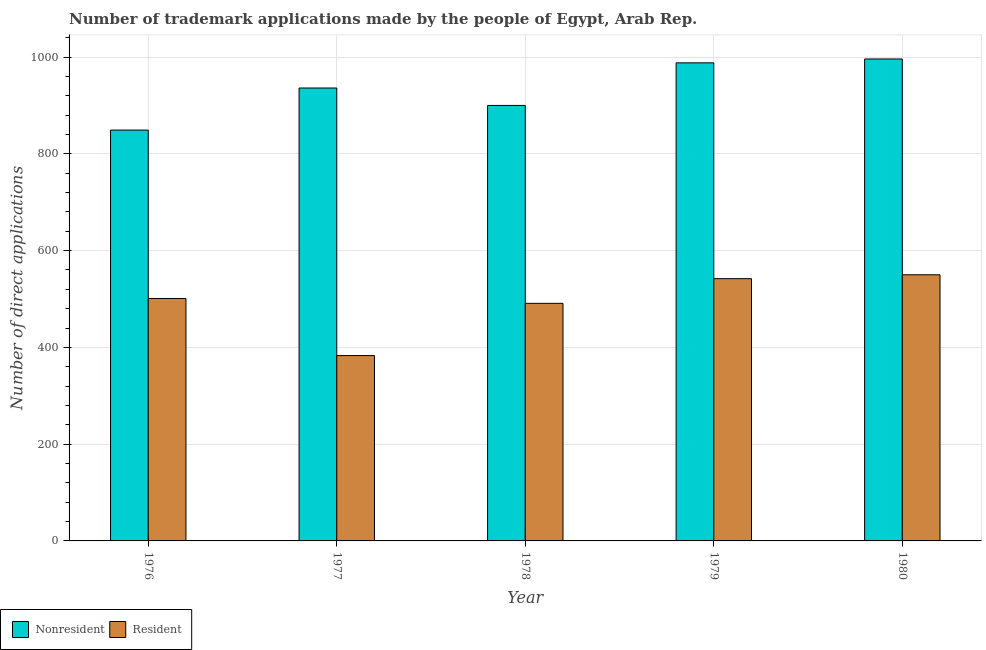Are the number of bars per tick equal to the number of legend labels?
Offer a very short reply. Yes. How many bars are there on the 1st tick from the left?
Keep it short and to the point. 2. How many bars are there on the 3rd tick from the right?
Give a very brief answer. 2. What is the label of the 3rd group of bars from the left?
Your answer should be very brief. 1978. What is the number of trademark applications made by non residents in 1979?
Provide a short and direct response. 988. Across all years, what is the maximum number of trademark applications made by residents?
Offer a terse response. 550. Across all years, what is the minimum number of trademark applications made by residents?
Ensure brevity in your answer.  383. In which year was the number of trademark applications made by residents maximum?
Make the answer very short. 1980. In which year was the number of trademark applications made by residents minimum?
Your response must be concise. 1977. What is the total number of trademark applications made by non residents in the graph?
Provide a short and direct response. 4669. What is the difference between the number of trademark applications made by residents in 1976 and that in 1979?
Offer a terse response. -41. What is the difference between the number of trademark applications made by residents in 1979 and the number of trademark applications made by non residents in 1978?
Give a very brief answer. 51. What is the average number of trademark applications made by residents per year?
Your answer should be compact. 493.4. In the year 1980, what is the difference between the number of trademark applications made by non residents and number of trademark applications made by residents?
Your response must be concise. 0. In how many years, is the number of trademark applications made by non residents greater than 400?
Ensure brevity in your answer.  5. What is the ratio of the number of trademark applications made by residents in 1976 to that in 1977?
Ensure brevity in your answer.  1.31. Is the number of trademark applications made by residents in 1978 less than that in 1980?
Your response must be concise. Yes. Is the difference between the number of trademark applications made by non residents in 1978 and 1980 greater than the difference between the number of trademark applications made by residents in 1978 and 1980?
Give a very brief answer. No. What is the difference between the highest and the lowest number of trademark applications made by non residents?
Offer a terse response. 147. In how many years, is the number of trademark applications made by residents greater than the average number of trademark applications made by residents taken over all years?
Offer a very short reply. 3. What does the 2nd bar from the left in 1977 represents?
Provide a short and direct response. Resident. What does the 1st bar from the right in 1977 represents?
Make the answer very short. Resident. How many bars are there?
Make the answer very short. 10. What is the difference between two consecutive major ticks on the Y-axis?
Provide a succinct answer. 200. Does the graph contain any zero values?
Provide a short and direct response. No. How are the legend labels stacked?
Provide a short and direct response. Horizontal. What is the title of the graph?
Provide a succinct answer. Number of trademark applications made by the people of Egypt, Arab Rep. What is the label or title of the X-axis?
Provide a short and direct response. Year. What is the label or title of the Y-axis?
Your response must be concise. Number of direct applications. What is the Number of direct applications of Nonresident in 1976?
Keep it short and to the point. 849. What is the Number of direct applications in Resident in 1976?
Offer a terse response. 501. What is the Number of direct applications of Nonresident in 1977?
Your answer should be compact. 936. What is the Number of direct applications in Resident in 1977?
Ensure brevity in your answer.  383. What is the Number of direct applications in Nonresident in 1978?
Offer a terse response. 900. What is the Number of direct applications in Resident in 1978?
Your answer should be very brief. 491. What is the Number of direct applications of Nonresident in 1979?
Provide a short and direct response. 988. What is the Number of direct applications of Resident in 1979?
Give a very brief answer. 542. What is the Number of direct applications in Nonresident in 1980?
Make the answer very short. 996. What is the Number of direct applications of Resident in 1980?
Offer a terse response. 550. Across all years, what is the maximum Number of direct applications in Nonresident?
Ensure brevity in your answer.  996. Across all years, what is the maximum Number of direct applications in Resident?
Your answer should be compact. 550. Across all years, what is the minimum Number of direct applications in Nonresident?
Your response must be concise. 849. Across all years, what is the minimum Number of direct applications of Resident?
Provide a succinct answer. 383. What is the total Number of direct applications in Nonresident in the graph?
Keep it short and to the point. 4669. What is the total Number of direct applications of Resident in the graph?
Make the answer very short. 2467. What is the difference between the Number of direct applications of Nonresident in 1976 and that in 1977?
Your answer should be compact. -87. What is the difference between the Number of direct applications of Resident in 1976 and that in 1977?
Make the answer very short. 118. What is the difference between the Number of direct applications in Nonresident in 1976 and that in 1978?
Ensure brevity in your answer.  -51. What is the difference between the Number of direct applications of Nonresident in 1976 and that in 1979?
Provide a short and direct response. -139. What is the difference between the Number of direct applications of Resident in 1976 and that in 1979?
Offer a terse response. -41. What is the difference between the Number of direct applications of Nonresident in 1976 and that in 1980?
Provide a succinct answer. -147. What is the difference between the Number of direct applications in Resident in 1976 and that in 1980?
Provide a succinct answer. -49. What is the difference between the Number of direct applications of Nonresident in 1977 and that in 1978?
Your response must be concise. 36. What is the difference between the Number of direct applications of Resident in 1977 and that in 1978?
Keep it short and to the point. -108. What is the difference between the Number of direct applications of Nonresident in 1977 and that in 1979?
Make the answer very short. -52. What is the difference between the Number of direct applications in Resident in 1977 and that in 1979?
Provide a succinct answer. -159. What is the difference between the Number of direct applications in Nonresident in 1977 and that in 1980?
Provide a short and direct response. -60. What is the difference between the Number of direct applications in Resident in 1977 and that in 1980?
Keep it short and to the point. -167. What is the difference between the Number of direct applications in Nonresident in 1978 and that in 1979?
Offer a terse response. -88. What is the difference between the Number of direct applications in Resident in 1978 and that in 1979?
Keep it short and to the point. -51. What is the difference between the Number of direct applications in Nonresident in 1978 and that in 1980?
Your answer should be very brief. -96. What is the difference between the Number of direct applications in Resident in 1978 and that in 1980?
Give a very brief answer. -59. What is the difference between the Number of direct applications in Resident in 1979 and that in 1980?
Your response must be concise. -8. What is the difference between the Number of direct applications in Nonresident in 1976 and the Number of direct applications in Resident in 1977?
Ensure brevity in your answer.  466. What is the difference between the Number of direct applications of Nonresident in 1976 and the Number of direct applications of Resident in 1978?
Ensure brevity in your answer.  358. What is the difference between the Number of direct applications in Nonresident in 1976 and the Number of direct applications in Resident in 1979?
Your answer should be very brief. 307. What is the difference between the Number of direct applications in Nonresident in 1976 and the Number of direct applications in Resident in 1980?
Give a very brief answer. 299. What is the difference between the Number of direct applications of Nonresident in 1977 and the Number of direct applications of Resident in 1978?
Make the answer very short. 445. What is the difference between the Number of direct applications in Nonresident in 1977 and the Number of direct applications in Resident in 1979?
Give a very brief answer. 394. What is the difference between the Number of direct applications of Nonresident in 1977 and the Number of direct applications of Resident in 1980?
Keep it short and to the point. 386. What is the difference between the Number of direct applications of Nonresident in 1978 and the Number of direct applications of Resident in 1979?
Provide a short and direct response. 358. What is the difference between the Number of direct applications of Nonresident in 1978 and the Number of direct applications of Resident in 1980?
Offer a very short reply. 350. What is the difference between the Number of direct applications of Nonresident in 1979 and the Number of direct applications of Resident in 1980?
Your answer should be compact. 438. What is the average Number of direct applications of Nonresident per year?
Your answer should be very brief. 933.8. What is the average Number of direct applications of Resident per year?
Offer a terse response. 493.4. In the year 1976, what is the difference between the Number of direct applications of Nonresident and Number of direct applications of Resident?
Give a very brief answer. 348. In the year 1977, what is the difference between the Number of direct applications of Nonresident and Number of direct applications of Resident?
Keep it short and to the point. 553. In the year 1978, what is the difference between the Number of direct applications of Nonresident and Number of direct applications of Resident?
Make the answer very short. 409. In the year 1979, what is the difference between the Number of direct applications in Nonresident and Number of direct applications in Resident?
Ensure brevity in your answer.  446. In the year 1980, what is the difference between the Number of direct applications of Nonresident and Number of direct applications of Resident?
Give a very brief answer. 446. What is the ratio of the Number of direct applications in Nonresident in 1976 to that in 1977?
Keep it short and to the point. 0.91. What is the ratio of the Number of direct applications of Resident in 1976 to that in 1977?
Your answer should be compact. 1.31. What is the ratio of the Number of direct applications of Nonresident in 1976 to that in 1978?
Your answer should be compact. 0.94. What is the ratio of the Number of direct applications of Resident in 1976 to that in 1978?
Give a very brief answer. 1.02. What is the ratio of the Number of direct applications in Nonresident in 1976 to that in 1979?
Keep it short and to the point. 0.86. What is the ratio of the Number of direct applications in Resident in 1976 to that in 1979?
Make the answer very short. 0.92. What is the ratio of the Number of direct applications in Nonresident in 1976 to that in 1980?
Make the answer very short. 0.85. What is the ratio of the Number of direct applications in Resident in 1976 to that in 1980?
Keep it short and to the point. 0.91. What is the ratio of the Number of direct applications of Nonresident in 1977 to that in 1978?
Offer a very short reply. 1.04. What is the ratio of the Number of direct applications of Resident in 1977 to that in 1978?
Offer a very short reply. 0.78. What is the ratio of the Number of direct applications in Nonresident in 1977 to that in 1979?
Your answer should be compact. 0.95. What is the ratio of the Number of direct applications in Resident in 1977 to that in 1979?
Your response must be concise. 0.71. What is the ratio of the Number of direct applications of Nonresident in 1977 to that in 1980?
Make the answer very short. 0.94. What is the ratio of the Number of direct applications of Resident in 1977 to that in 1980?
Provide a succinct answer. 0.7. What is the ratio of the Number of direct applications in Nonresident in 1978 to that in 1979?
Offer a terse response. 0.91. What is the ratio of the Number of direct applications in Resident in 1978 to that in 1979?
Provide a succinct answer. 0.91. What is the ratio of the Number of direct applications of Nonresident in 1978 to that in 1980?
Provide a short and direct response. 0.9. What is the ratio of the Number of direct applications of Resident in 1978 to that in 1980?
Provide a short and direct response. 0.89. What is the ratio of the Number of direct applications of Nonresident in 1979 to that in 1980?
Offer a terse response. 0.99. What is the ratio of the Number of direct applications of Resident in 1979 to that in 1980?
Your response must be concise. 0.99. What is the difference between the highest and the lowest Number of direct applications of Nonresident?
Your response must be concise. 147. What is the difference between the highest and the lowest Number of direct applications of Resident?
Your response must be concise. 167. 